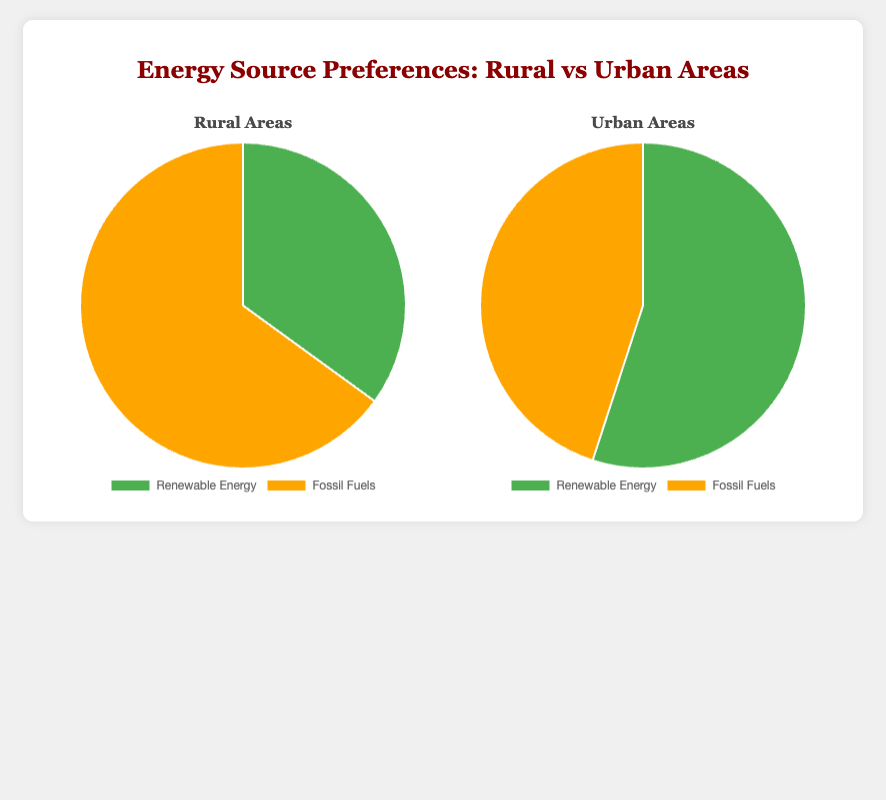What's the preference for renewable energy in rural areas? In the rural areas pie chart, the segment labeled "Renewable Energy" represents 35% of the energy preferences.
Answer: 35% What's the preference for fossil fuels in urban areas? In the urban areas pie chart, the segment labeled "Fossil Fuels" represents 45% of the energy preferences.
Answer: 45% How much more do rural areas prefer fossil fuels over renewable energy? In rural areas, the preference for fossil fuels is 65%, and for renewable energy, it is 35%. The difference is 65% - 35%.
Answer: 30% What is the combined percentage of renewable energy preference in both rural and urban areas? Renewable energy preferences in rural areas is 35% and in urban areas is 55%. Summing these two values gives 35% + 55%.
Answer: 90% Which area has a higher preference for renewable energy, rural or urban? In the pie chart, urban areas show a renewable energy preference of 55%, whereas rural areas show a 35% preference. Since 55% is greater than 35%, urban areas have a higher preference.
Answer: Urban By how much do urban areas prefer fossil fuels less than rural areas? Urban areas have a fossil fuel preference of 45%, and rural areas have 65%. The difference is 65% - 45%.
Answer: 20% What's the least preferred energy source in urban areas? In the urban areas pie chart, the smaller segment is labeled "Fossil Fuels" with a preference of 45%.
Answer: Fossil Fuels What's the total percentage of preference for both energy sources in rural areas? The preferences for renewable energy and fossil fuels in rural areas are 35% and 65%, respectively. Adding these percentages gives 35% + 65%.
Answer: 100% Compare the combined preference for fossil fuels in both rural and urban areas. Fossil fuel preferences in rural areas are 65% and in urban areas are 45%. The combined total is 65% + 45%.
Answer: 110% What color represents renewable energy in the urban areas pie chart? In the urban areas pie chart, the segment for renewable energy is colored green.
Answer: Green 